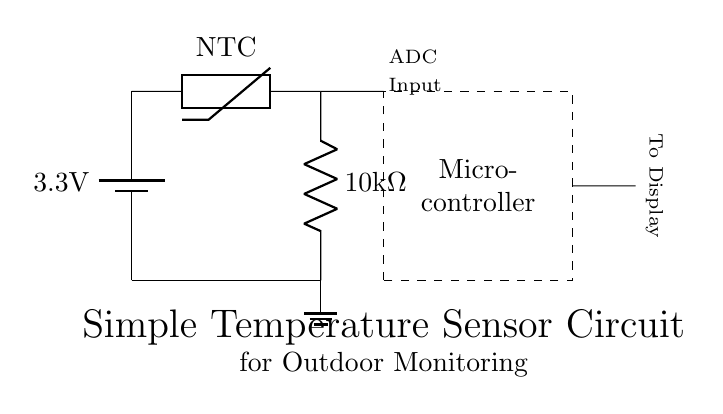What is the main power source for this circuit? The main power source is a 3.3V battery, indicated in the circuit diagram where it shows the battery symbol and the associated voltage label.
Answer: 3.3V battery What type of sensor is used in this circuit? The circuit uses an NTC (Negative Temperature Coefficient) thermistor for temperature sensing, as labeled in the diagram.
Answer: NTC thermistor What is the resistance value of the resistor in the circuit? The resistor connected in the circuit has a value labeled as 10k ohms, which can be read directly from the diagram.
Answer: 10k ohms What component is responsible for converting analog signals to digital signals? The microcontroller in the circuit performs the function of converting analog signals, received from the thermistor, into digital signals using its ADC (Analog to Digital Converter) input.
Answer: Microcontroller Which direction does the signal flow towards the display? The signal flows horizontally from the microcontroller to the display output, indicated by the arrows directing the flow towards the display component.
Answer: To Display Why is the thermistor placed in series with the resistor? The thermistor is placed in series with the resistor to create a voltage divider configuration, allowing the microcontroller to measure the varying voltage output based on the temperature changes.
Answer: Voltage divider What might happen if the battery voltage increases significantly? If the battery voltage increases significantly, it could exceed the operating voltage of the microcontroller and potentially damage the circuit or cause erroneous readings.
Answer: Overvoltage damage 